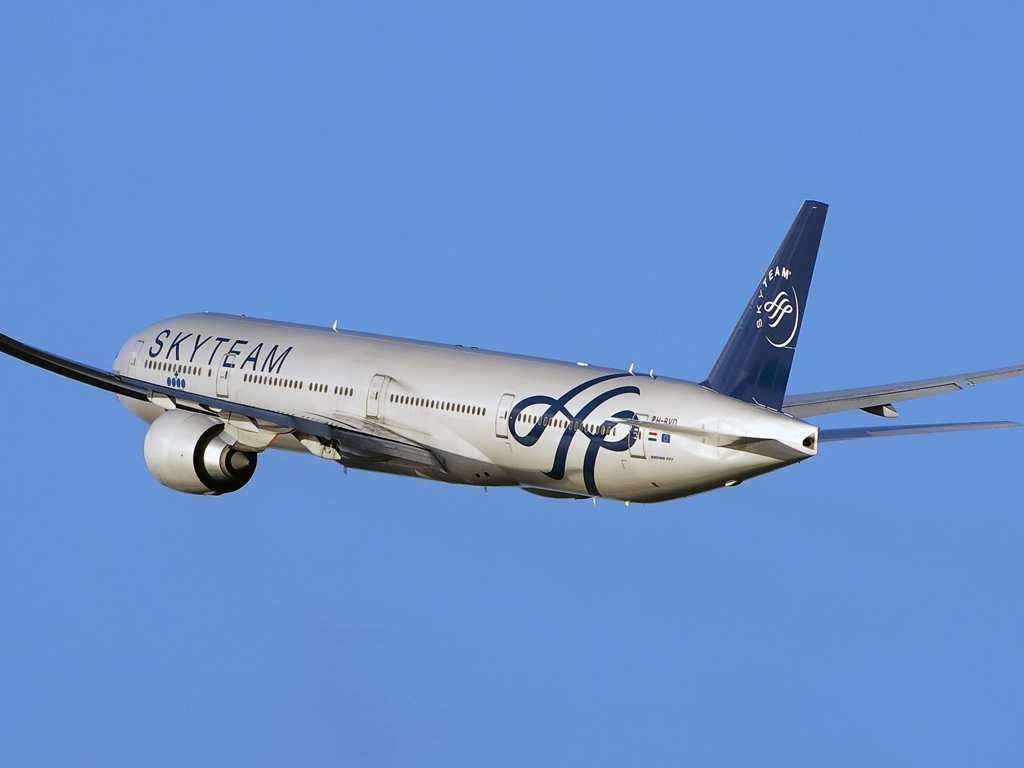Could you explain the significance of the logo on the tail of this airplane? The logo on the tail represents 'SkyTeam', which is a global airline alliance. This signifies that the airline operating this aircraft is part of a larger network of carriers that collaborate to provide passengers with a wider range of destinations, smoother connections, and shared benefits like lounge access and frequent flyer programs. 